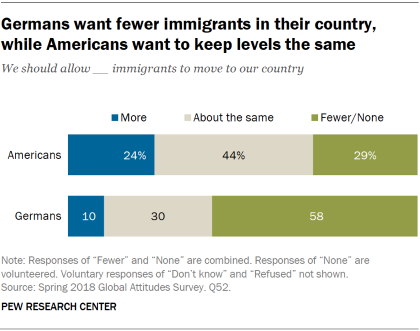Highlight a few significant elements in this photo. The aggregate value of More is 0.34... The color of the More is blue. 